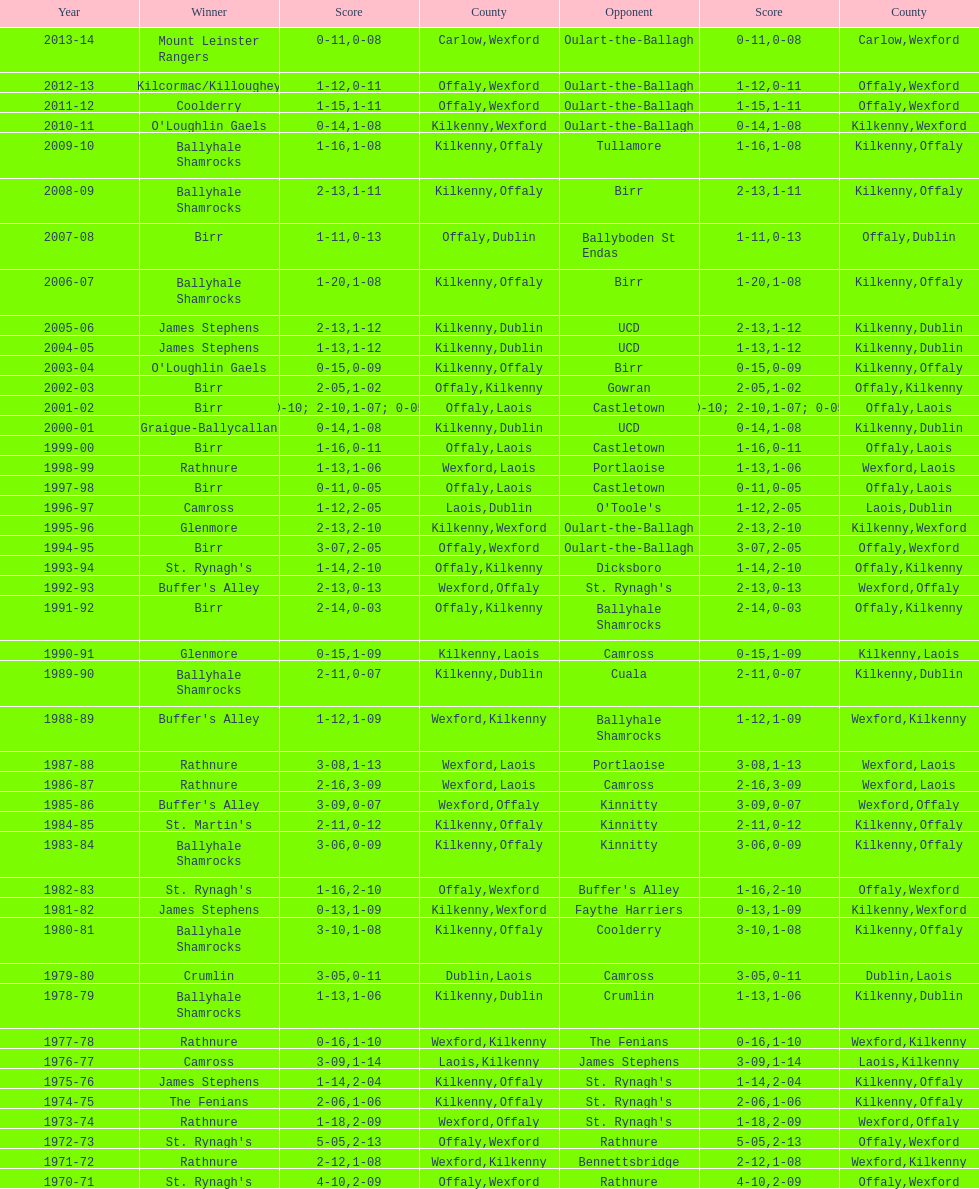Which winner is next to mount leinster rangers? Kilcormac/Killoughey. 